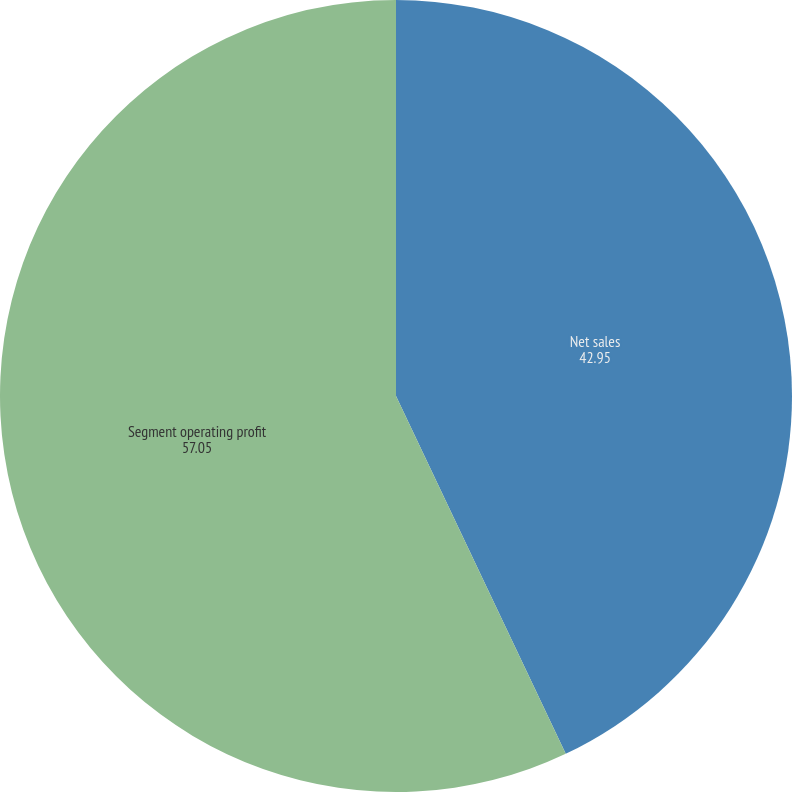Convert chart. <chart><loc_0><loc_0><loc_500><loc_500><pie_chart><fcel>Net sales<fcel>Segment operating profit<nl><fcel>42.95%<fcel>57.05%<nl></chart> 